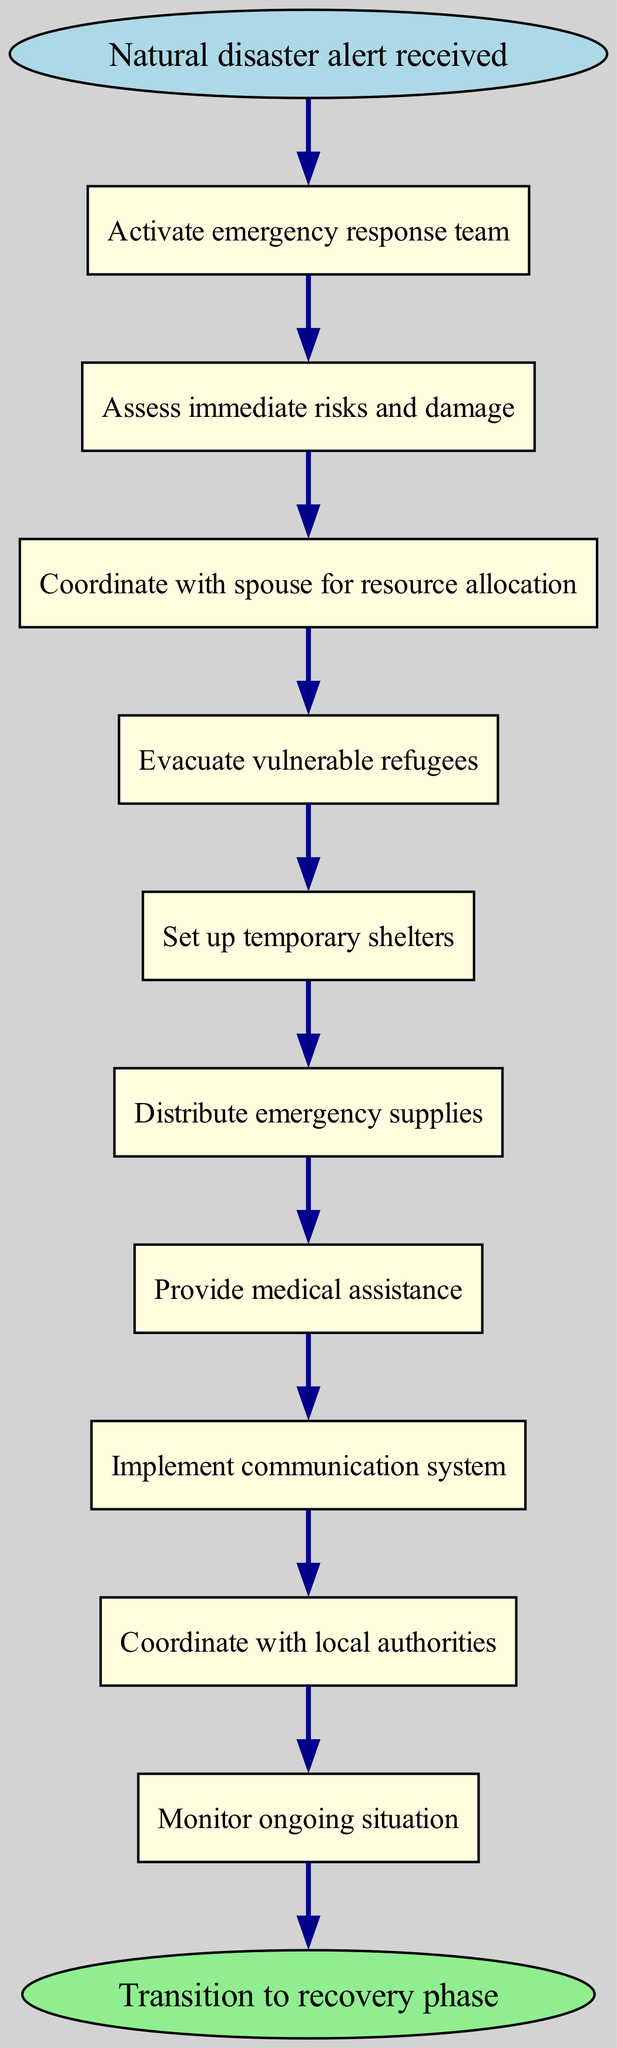What is the first step after receiving a natural disaster alert? The diagram indicates that the first step is to "Activate emergency response team," as it is the first node that follows the "Natural disaster alert received."
Answer: Activate emergency response team How many steps are there in the emergency response protocol? By counting the number of steps listed in the diagram from step 1 to step 10, we find there are a total of 10 steps.
Answer: 10 What step involves coordinating with the spouse? The diagram specifies that "Coordinate with spouse for resource allocation" is the step that involves collaboration with the spouse, as indicated by step 3.
Answer: Coordinate with spouse for resource allocation What are the steps following the evacuation of vulnerable refugees? After the step "Evacuate vulnerable refugees," the next steps, in order, are "Set up temporary shelters," then "Distribute emergency supplies," followed by "Provide medical assistance."
Answer: Set up temporary shelters; Distribute emergency supplies; Provide medical assistance What is the last action taken in the emergency response protocol? The final action before transitioning to the recovery phase is to "Monitor ongoing situation" as indicated in step 10 right before the "Transition to recovery phase."
Answer: Monitor ongoing situation What two steps are directly connected to the implementation of the communication system? The steps connected to "Implement communication system" are "Provide medical assistance," which comes before it, and "Coordinate with local authorities," which comes after it, as indicated by the arrows connecting these nodes.
Answer: Provide medical assistance; Coordinate with local authorities Which step is followed by distributing emergency supplies? The step that follows "Distribute emergency supplies" is "Provide medical assistance," as shown in the flow of the diagram.
Answer: Provide medical assistance What happens after assessing immediate risks and damage? The step that follows "Assess immediate risks and damage" is "Coordinate with spouse for resource allocation," indicating the evolution of the protocol post-assessment.
Answer: Coordinate with spouse for resource allocation 